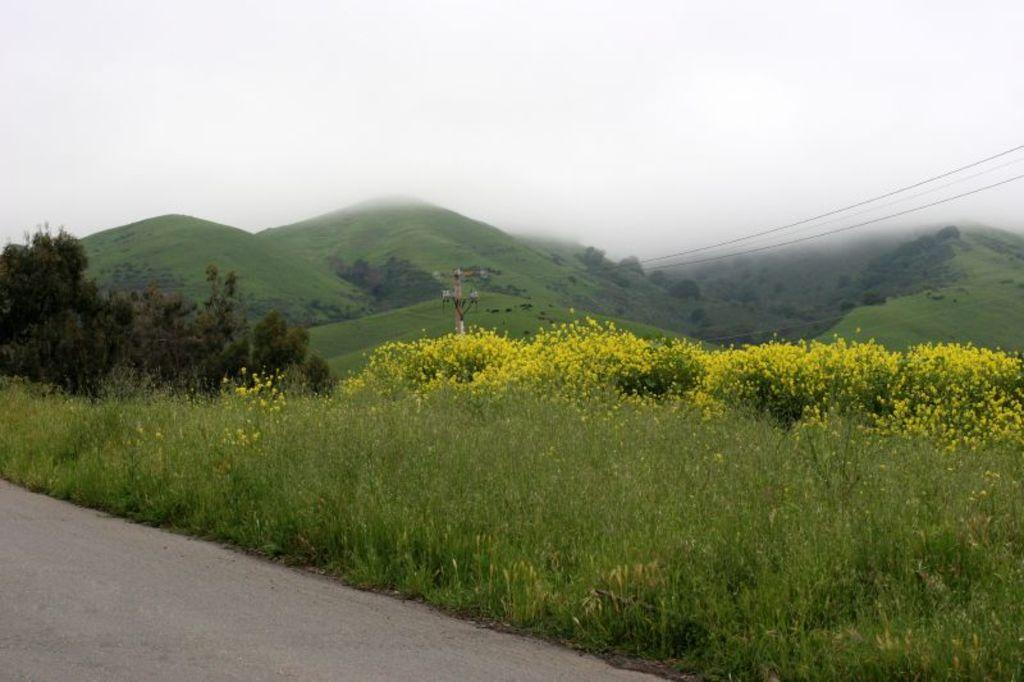What type of landform can be seen in the image? There is a hill in the image. What else is visible in the image besides the hill? Power line cables, grass, flowers, and the sky are visible in the image. What type of vegetation is present in the image? Grass and flowers are present in the image. What is visible at the top of the image? The sky is visible at the top of the image. What type of pan can be seen in the image? There is no pan present in the image. What is the hill doing in the image? The hill is not an active subject in the image; it is a stationary landform. 